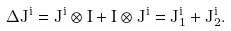Convert formula to latex. <formula><loc_0><loc_0><loc_500><loc_500>\Delta J ^ { i } = J ^ { i } \otimes I + I \otimes J ^ { i } = J _ { 1 } ^ { i } + J _ { 2 } ^ { i } .</formula> 